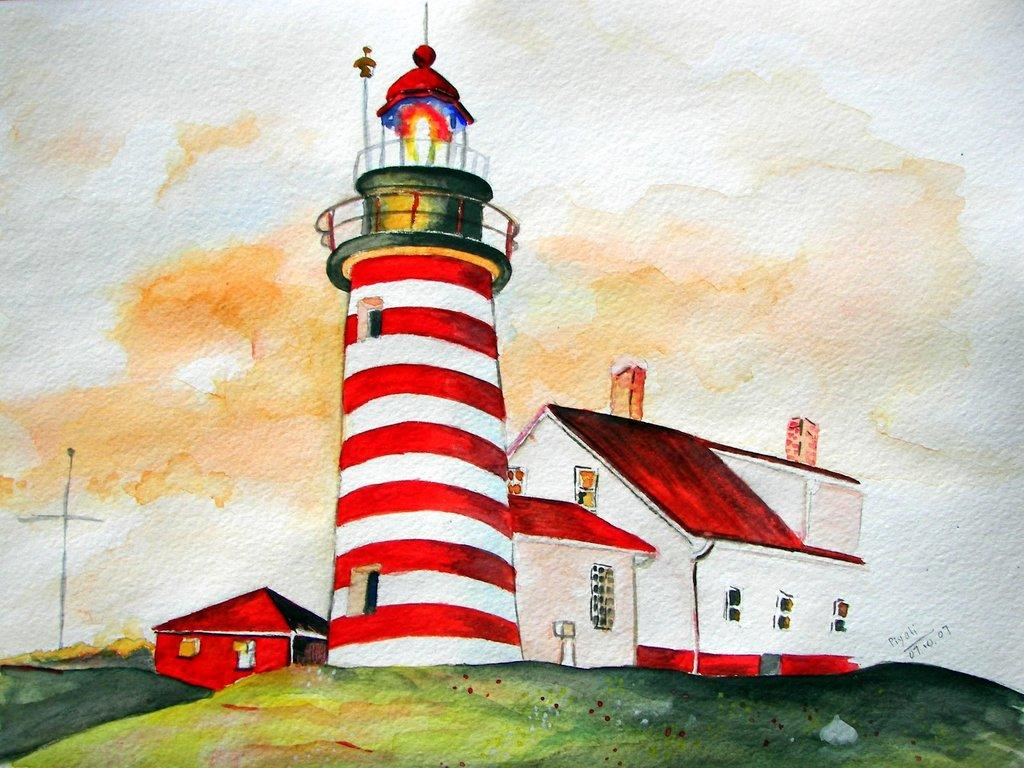What type of artwork is depicted in the image? The image is a painting. What structure can be seen in the painting? There is a house in the painting. What type of vegetation is present in the painting? There is grass in the painting. How many fairies are dancing on the grass in the painting? There are no fairies present in the painting; it only features a house and grass. What color is the toe of the person in the painting? There is no person depicted in the painting, only a house and grass. 